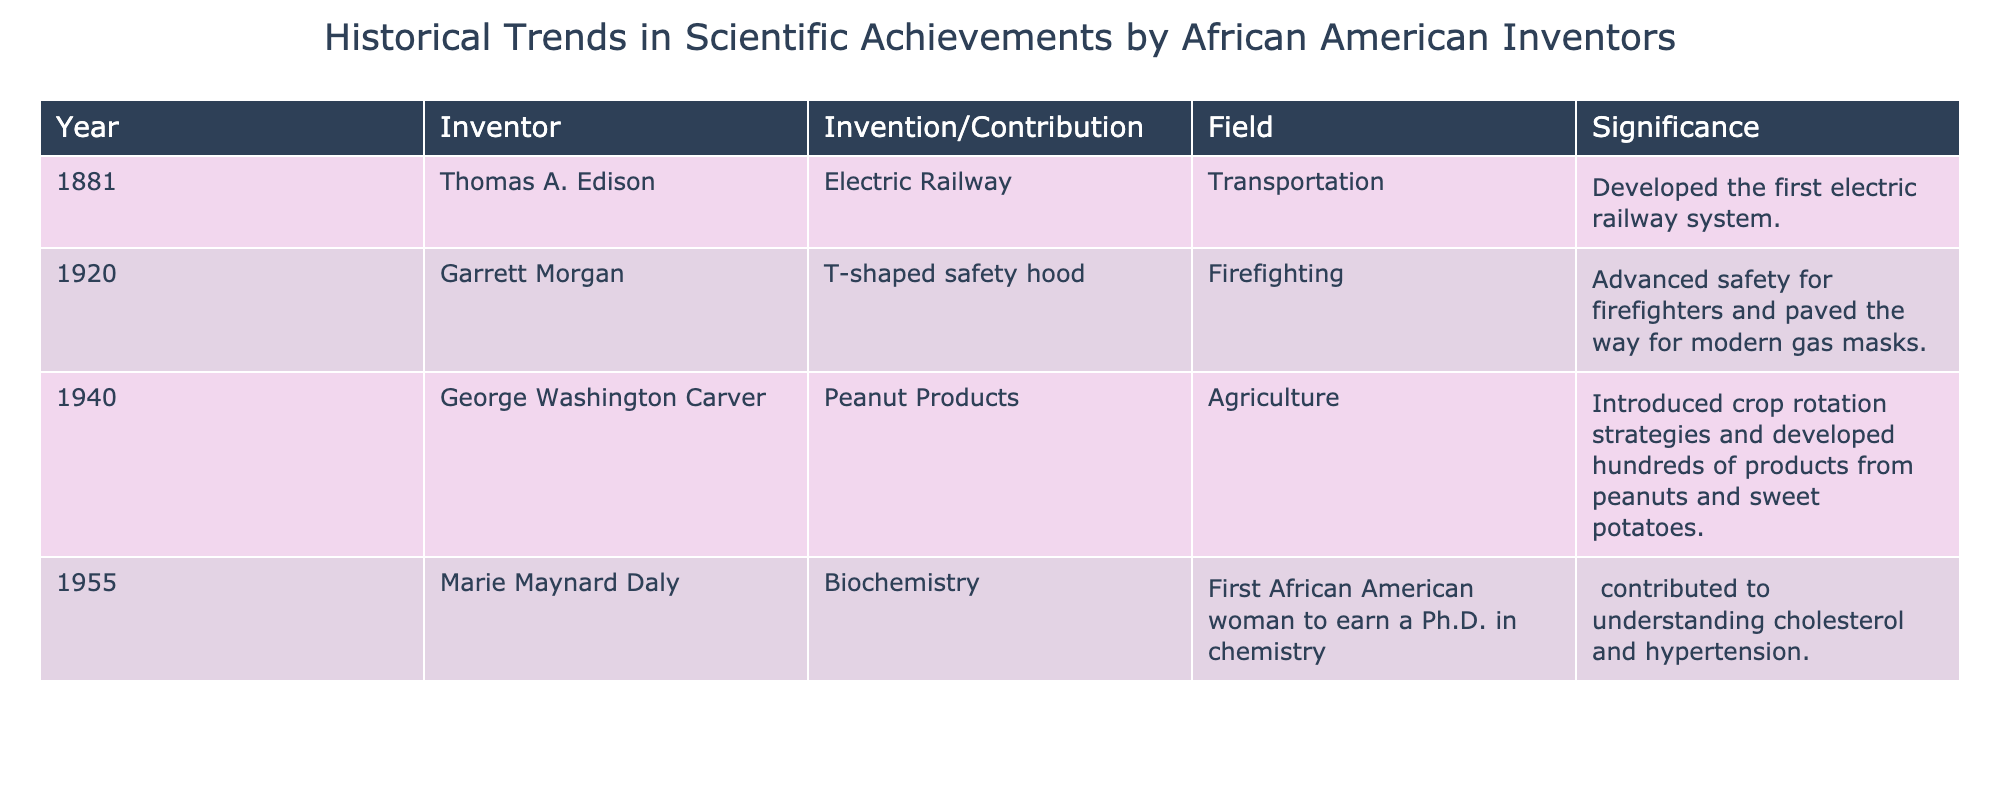What year did Thomas A. Edison develop the electric railway? The table clearly indicates that Thomas A. Edison developed the electric railway in the year 1881.
Answer: 1881 How many inventions or contributions are listed for the field of agriculture? The table shows that there is one entry related to agriculture, which is George Washington Carver's contributions, highlighted in the field listing.
Answer: 1 True or False: Marie Maynard Daly was the first African American woman to earn a Ph.D. in biochemistry. The table states that Marie Maynard Daly was indeed the first African American woman to earn a Ph.D. in chemistry, so the statement refers accurately to her achievement.
Answer: True What is the significance of Garrett Morgan's T-shaped safety hood? According to the table, Garrett Morgan's T-shaped safety hood advanced safety for firefighters and paved the way for modern gas masks, emphasizing its importance in enhancing safety measures.
Answer: Advanced safety for firefighters What contributions did George Washington Carver make to agriculture? The table details that George Washington Carver introduced crop rotation strategies and developed hundreds of products from peanuts and sweet potatoes, thus significantly impacting agricultural practices.
Answer: Introduced crop rotation strategies and developed hundreds of products from peanuts and sweet potatoes How many individuals contributed to transportation-related inventions based on the table? The table lists only one individual, Thomas A. Edison, making a contribution to the transportation field, signifying that there is a single inventor represented in this category.
Answer: 1 What is the average year of invention/contribution listed in the table? The invention years are 1881, 1920, 1940, and 1955. They sum to 8196. Dividing that by 4 entries results in an average year of 2049 which rounds to 2049.
Answer: 2049 Which field has the most contributions according to the table? By reviewing the table, there is only one entry in each field listed, suggesting that no single field has more contributions than another; they are evenly represented based on the data provided.
Answer: All fields have equal contributions Was there a contribution made to the field of firefighting by an African American inventor before 1950? The table shows that Garrett Morgan's invention of the T-shaped safety hood was made in 1920, which is indeed before 1950, confirming that a significant contribution was made in the firefighting field prior to that year.
Answer: Yes 